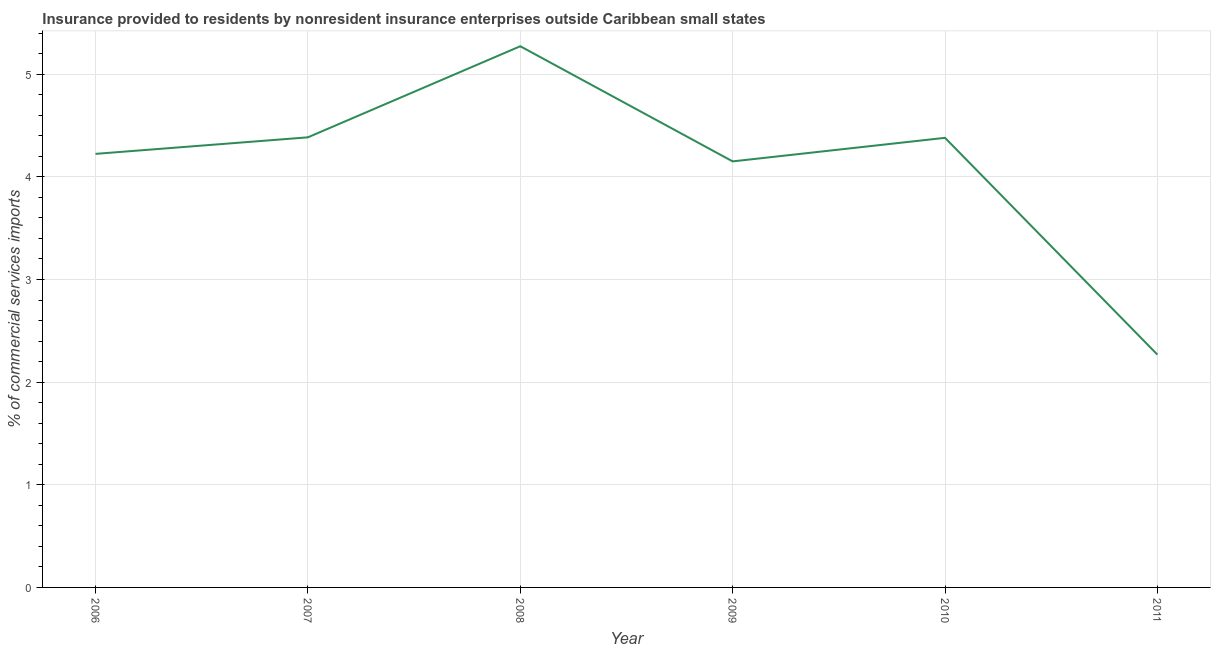What is the insurance provided by non-residents in 2007?
Offer a very short reply. 4.38. Across all years, what is the maximum insurance provided by non-residents?
Provide a short and direct response. 5.27. Across all years, what is the minimum insurance provided by non-residents?
Your response must be concise. 2.27. In which year was the insurance provided by non-residents minimum?
Provide a succinct answer. 2011. What is the sum of the insurance provided by non-residents?
Offer a very short reply. 24.68. What is the difference between the insurance provided by non-residents in 2007 and 2008?
Your answer should be very brief. -0.89. What is the average insurance provided by non-residents per year?
Make the answer very short. 4.11. What is the median insurance provided by non-residents?
Keep it short and to the point. 4.3. What is the ratio of the insurance provided by non-residents in 2008 to that in 2010?
Make the answer very short. 1.2. Is the insurance provided by non-residents in 2009 less than that in 2010?
Give a very brief answer. Yes. Is the difference between the insurance provided by non-residents in 2009 and 2010 greater than the difference between any two years?
Ensure brevity in your answer.  No. What is the difference between the highest and the second highest insurance provided by non-residents?
Your response must be concise. 0.89. What is the difference between the highest and the lowest insurance provided by non-residents?
Provide a succinct answer. 3. Does the insurance provided by non-residents monotonically increase over the years?
Keep it short and to the point. No. How many years are there in the graph?
Keep it short and to the point. 6. What is the difference between two consecutive major ticks on the Y-axis?
Your answer should be very brief. 1. Does the graph contain grids?
Ensure brevity in your answer.  Yes. What is the title of the graph?
Your answer should be compact. Insurance provided to residents by nonresident insurance enterprises outside Caribbean small states. What is the label or title of the X-axis?
Your response must be concise. Year. What is the label or title of the Y-axis?
Keep it short and to the point. % of commercial services imports. What is the % of commercial services imports of 2006?
Give a very brief answer. 4.22. What is the % of commercial services imports of 2007?
Offer a terse response. 4.38. What is the % of commercial services imports of 2008?
Provide a short and direct response. 5.27. What is the % of commercial services imports in 2009?
Offer a terse response. 4.15. What is the % of commercial services imports in 2010?
Ensure brevity in your answer.  4.38. What is the % of commercial services imports of 2011?
Give a very brief answer. 2.27. What is the difference between the % of commercial services imports in 2006 and 2007?
Offer a very short reply. -0.16. What is the difference between the % of commercial services imports in 2006 and 2008?
Your answer should be very brief. -1.05. What is the difference between the % of commercial services imports in 2006 and 2009?
Your answer should be very brief. 0.07. What is the difference between the % of commercial services imports in 2006 and 2010?
Make the answer very short. -0.16. What is the difference between the % of commercial services imports in 2006 and 2011?
Make the answer very short. 1.96. What is the difference between the % of commercial services imports in 2007 and 2008?
Your response must be concise. -0.89. What is the difference between the % of commercial services imports in 2007 and 2009?
Your answer should be very brief. 0.23. What is the difference between the % of commercial services imports in 2007 and 2010?
Make the answer very short. 0. What is the difference between the % of commercial services imports in 2007 and 2011?
Give a very brief answer. 2.12. What is the difference between the % of commercial services imports in 2008 and 2009?
Provide a short and direct response. 1.12. What is the difference between the % of commercial services imports in 2008 and 2010?
Ensure brevity in your answer.  0.89. What is the difference between the % of commercial services imports in 2008 and 2011?
Your response must be concise. 3. What is the difference between the % of commercial services imports in 2009 and 2010?
Offer a very short reply. -0.23. What is the difference between the % of commercial services imports in 2009 and 2011?
Ensure brevity in your answer.  1.88. What is the difference between the % of commercial services imports in 2010 and 2011?
Offer a very short reply. 2.11. What is the ratio of the % of commercial services imports in 2006 to that in 2008?
Ensure brevity in your answer.  0.8. What is the ratio of the % of commercial services imports in 2006 to that in 2011?
Your answer should be compact. 1.86. What is the ratio of the % of commercial services imports in 2007 to that in 2008?
Your response must be concise. 0.83. What is the ratio of the % of commercial services imports in 2007 to that in 2009?
Ensure brevity in your answer.  1.06. What is the ratio of the % of commercial services imports in 2007 to that in 2011?
Keep it short and to the point. 1.93. What is the ratio of the % of commercial services imports in 2008 to that in 2009?
Your answer should be compact. 1.27. What is the ratio of the % of commercial services imports in 2008 to that in 2010?
Make the answer very short. 1.2. What is the ratio of the % of commercial services imports in 2008 to that in 2011?
Your answer should be very brief. 2.33. What is the ratio of the % of commercial services imports in 2009 to that in 2010?
Your answer should be very brief. 0.95. What is the ratio of the % of commercial services imports in 2009 to that in 2011?
Keep it short and to the point. 1.83. What is the ratio of the % of commercial services imports in 2010 to that in 2011?
Ensure brevity in your answer.  1.93. 